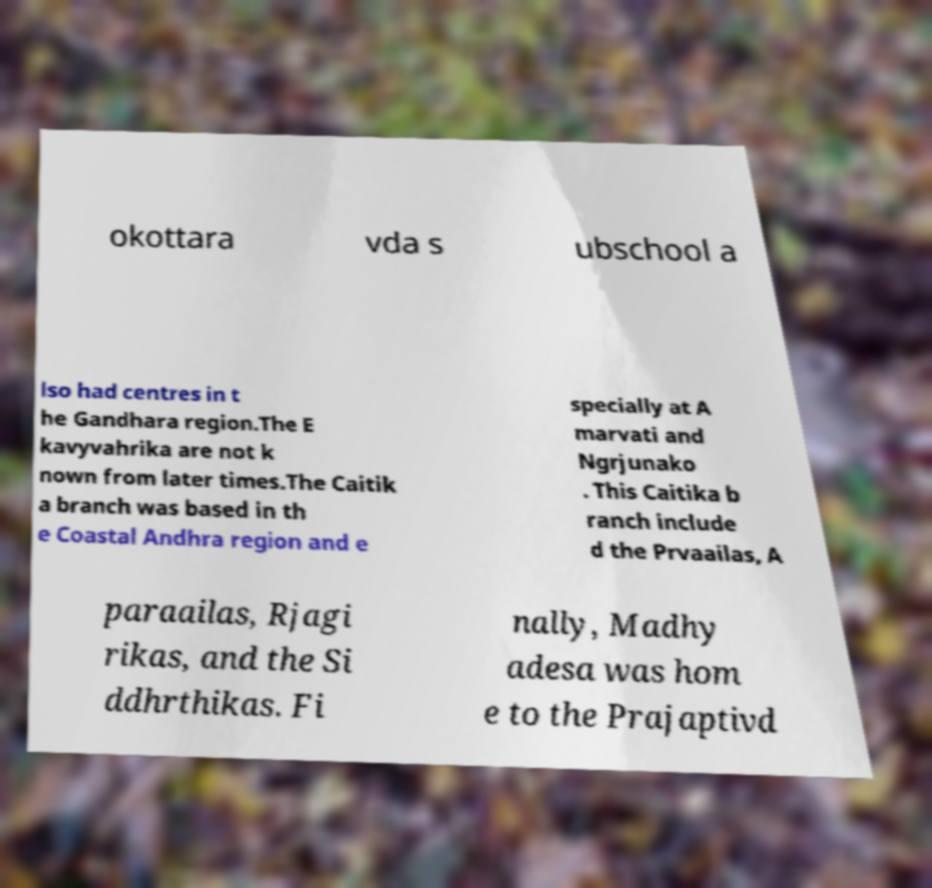Could you extract and type out the text from this image? okottara vda s ubschool a lso had centres in t he Gandhara region.The E kavyvahrika are not k nown from later times.The Caitik a branch was based in th e Coastal Andhra region and e specially at A marvati and Ngrjunako . This Caitika b ranch include d the Prvaailas, A paraailas, Rjagi rikas, and the Si ddhrthikas. Fi nally, Madhy adesa was hom e to the Prajaptivd 